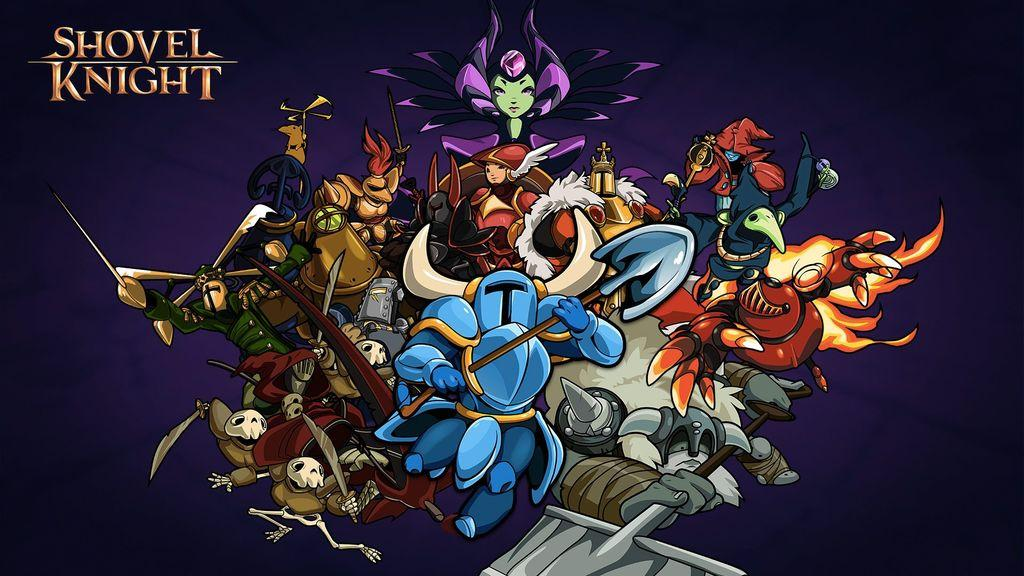What is the main subject of the poster in the image? The main subject of the poster in the image is a cartoon program. Can you describe the content of the poster? The poster contains multiple cartoon characters. Where is the text located on the poster? The text is present in the top left side of the poster. How many rabbits are featured in the poster? There is no mention of rabbits in the image or the provided facts, so we cannot determine if any rabbits are present. 